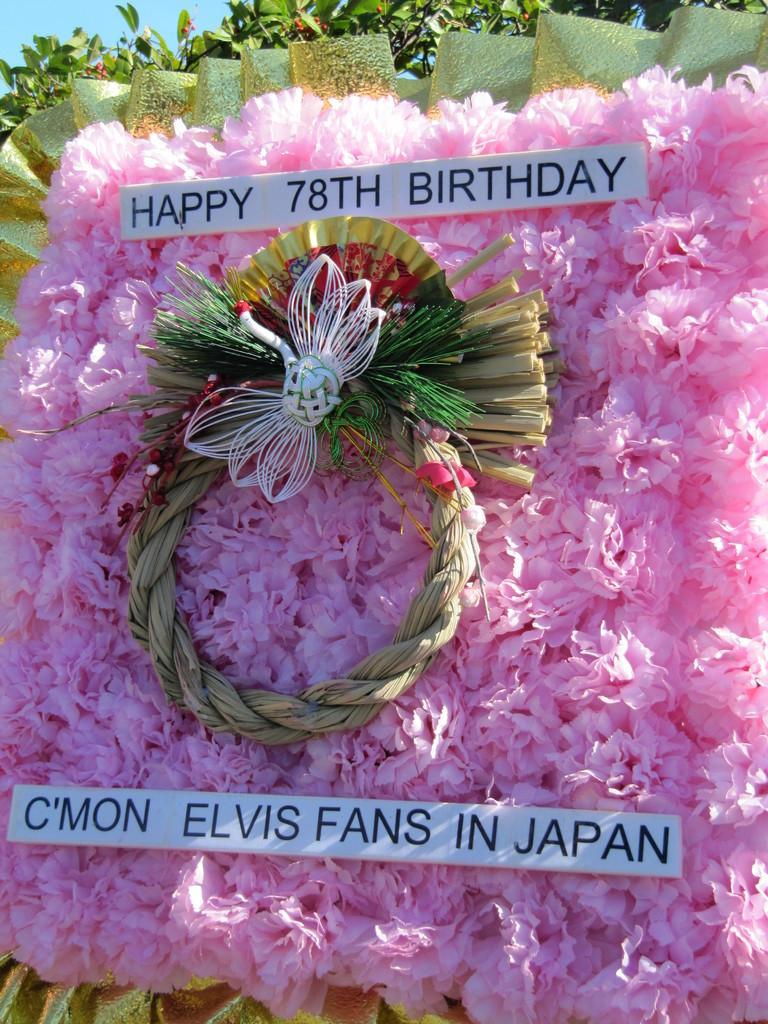Can you describe this image briefly? These are the paper flowers in pink color and there is a board of 78th birthday, behind it there are leaves. 